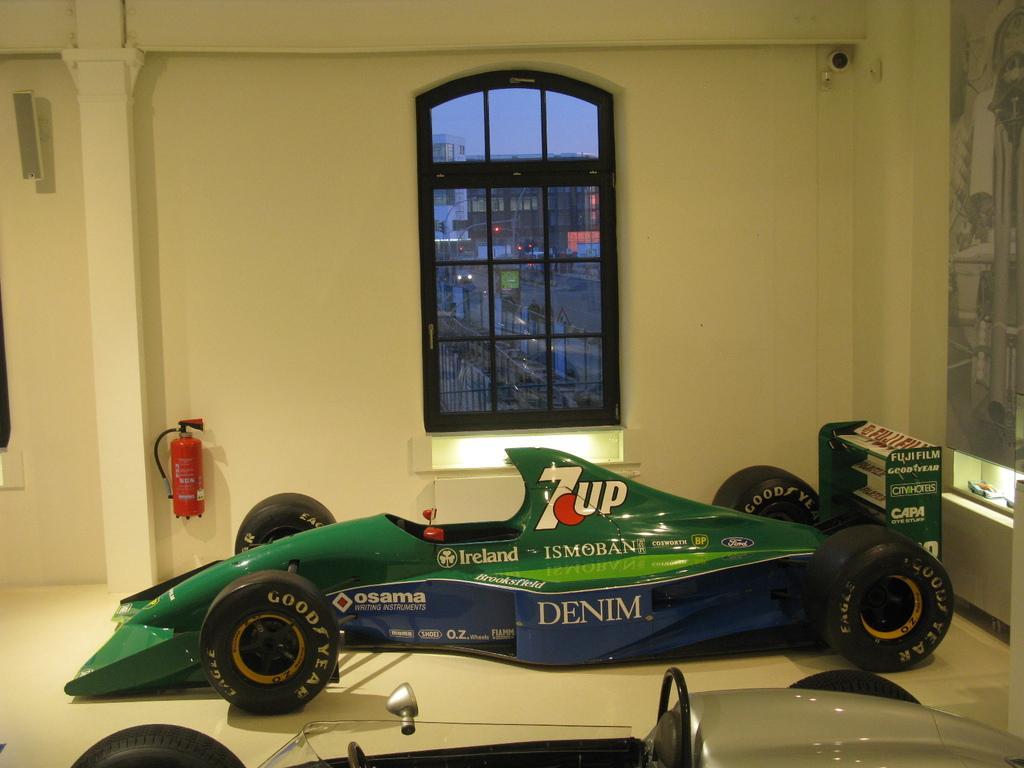How would you summarize this image in a sentence or two? In the image there is a green formula car inside a building and behind it there is a window on the wall with a fire exhaust cylinder on the left side. in the front there is another car. 